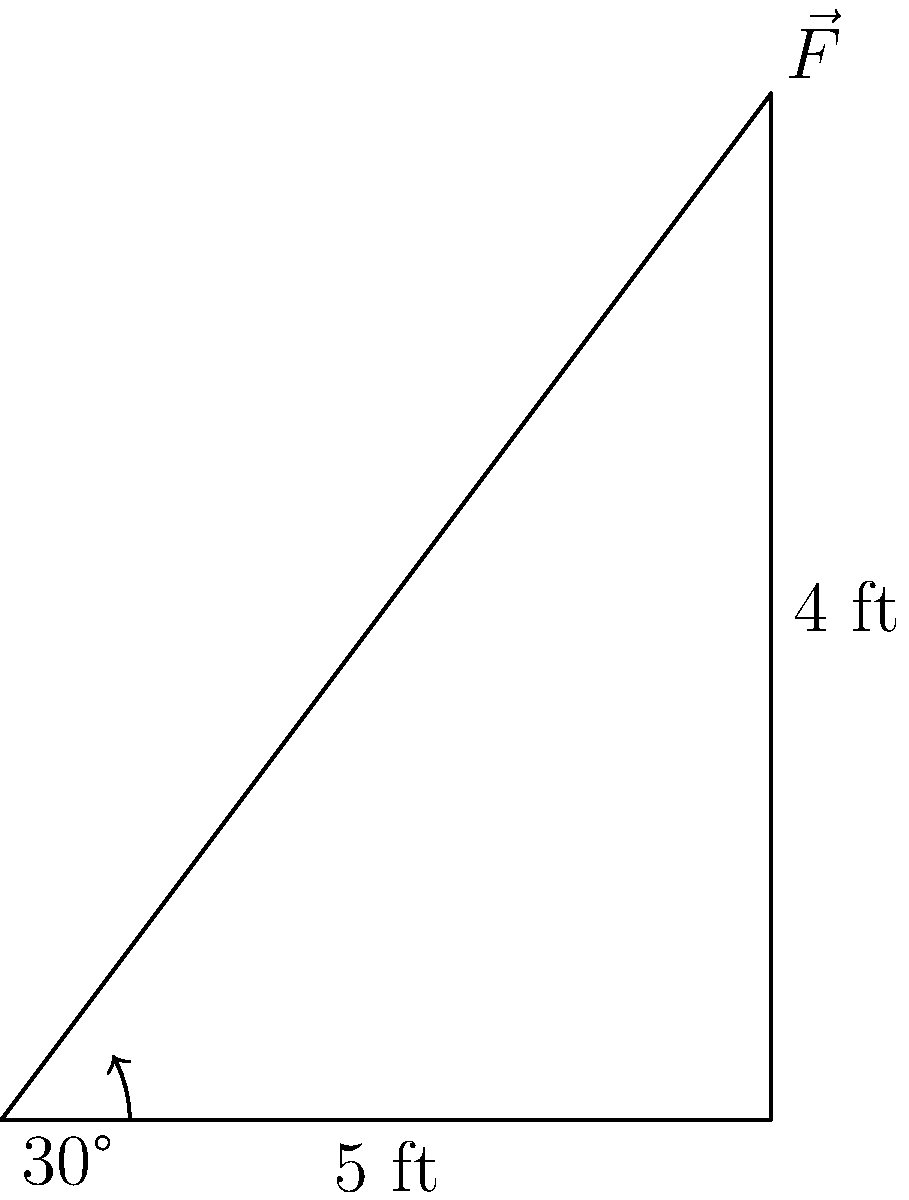You're moving your great-grandfather's antique oak dresser across your living room floor. The dresser weighs 200 lbs, and you need to apply a force at a 30° angle to the floor to move it. If the coefficient of friction between the dresser and the floor is 0.4, what magnitude of force (in lbs) do you need to apply to start moving the dresser? Let's approach this step-by-step, using principles that align with traditional values of hard work and practical problem-solving:

1) First, we need to calculate the normal force. Since the dresser is on a flat surface, the normal force equals the weight:
   $N = 200 \text{ lbs}$

2) Now, we can calculate the force of friction:
   $F_f = \mu N = 0.4 \times 200 = 80 \text{ lbs}$

3) To move the dresser, our applied force must overcome this friction. We need to consider the component of our force that's parallel to the floor:
   $F \cos(30°) = 80 \text{ lbs}$

4) Now we can solve for $F$:
   $F = \frac{80}{\cos(30°)} = \frac{80}{0.866} \approx 92.37 \text{ lbs}$

5) Rounding up to ensure we definitely move the dresser (always better to be prepared):
   $F \approx 93 \text{ lbs}$

This shows that with good old-fashioned elbow grease and some smart thinking, we can tackle even tough moving jobs!
Answer: 93 lbs 